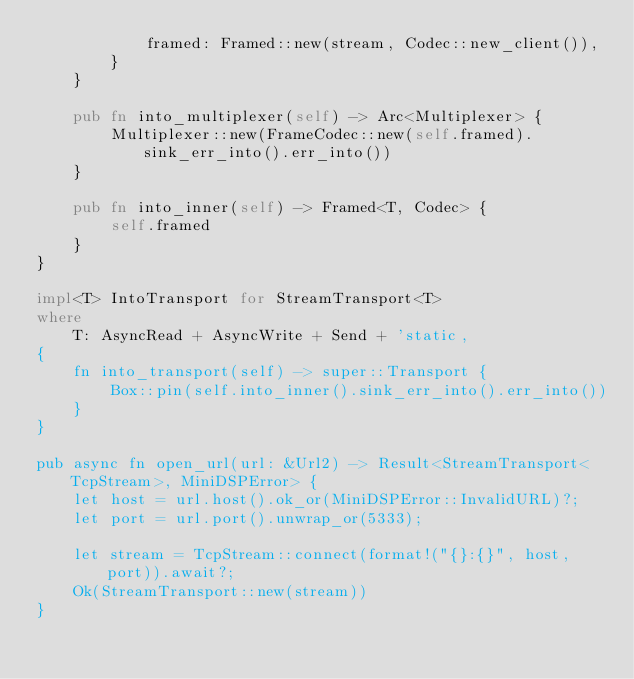Convert code to text. <code><loc_0><loc_0><loc_500><loc_500><_Rust_>            framed: Framed::new(stream, Codec::new_client()),
        }
    }

    pub fn into_multiplexer(self) -> Arc<Multiplexer> {
        Multiplexer::new(FrameCodec::new(self.framed).sink_err_into().err_into())
    }

    pub fn into_inner(self) -> Framed<T, Codec> {
        self.framed
    }
}

impl<T> IntoTransport for StreamTransport<T>
where
    T: AsyncRead + AsyncWrite + Send + 'static,
{
    fn into_transport(self) -> super::Transport {
        Box::pin(self.into_inner().sink_err_into().err_into())
    }
}

pub async fn open_url(url: &Url2) -> Result<StreamTransport<TcpStream>, MiniDSPError> {
    let host = url.host().ok_or(MiniDSPError::InvalidURL)?;
    let port = url.port().unwrap_or(5333);

    let stream = TcpStream::connect(format!("{}:{}", host, port)).await?;
    Ok(StreamTransport::new(stream))
}
</code> 